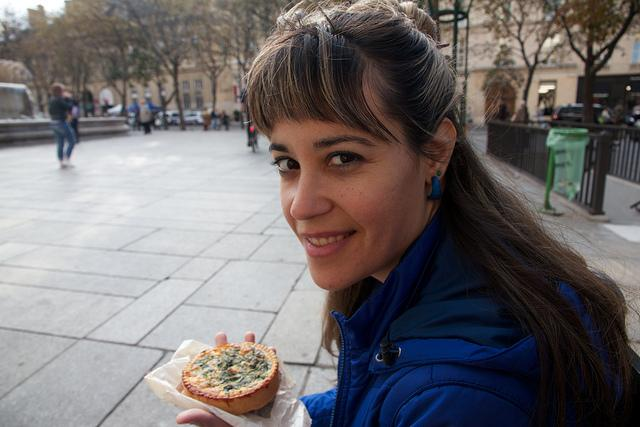What material are the earrings made of?

Choices:
A) crystal
B) jade
C) metal
D) plastic metal 